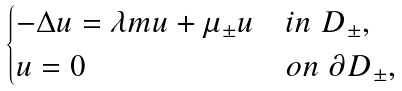<formula> <loc_0><loc_0><loc_500><loc_500>\begin{cases} - \Delta u = \lambda m u + \mu _ { \pm } u & i n \ D _ { \pm } , \\ u = 0 & o n \ \partial D _ { \pm } , \end{cases}</formula> 